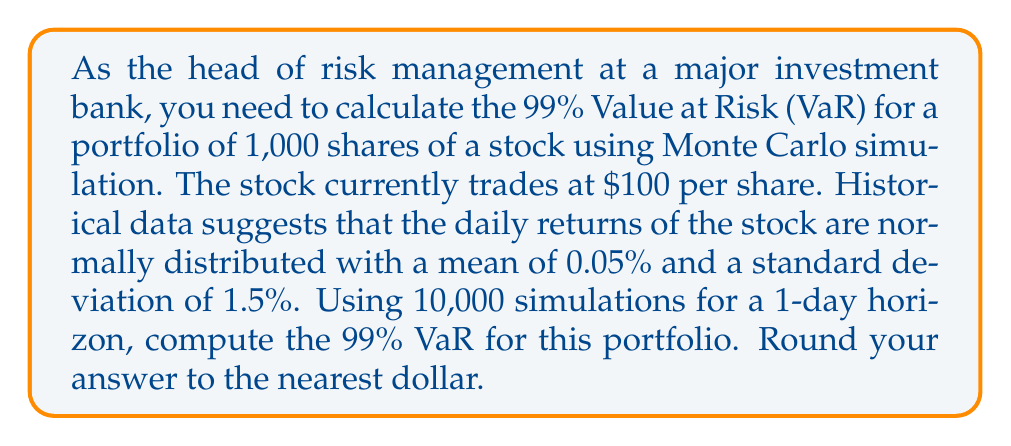What is the answer to this math problem? To solve this problem, we'll follow these steps:

1) Set up the Monte Carlo simulation:
   - Number of simulations: 10,000
   - Current portfolio value: $100,000 (1,000 shares at $100 each)
   - Mean daily return: 0.05% = 0.0005
   - Standard deviation of daily returns: 1.5% = 0.015

2) For each simulation:
   a) Generate a random number from a standard normal distribution (Z)
   b) Calculate the simulated return: $R = \mu + \sigma Z$
   c) Calculate the simulated portfolio value: $V = V_0 (1 + R)$

3) After all simulations:
   a) Sort the simulated portfolio values
   b) Find the 1st percentile (since we want 99% VaR)
   c) Calculate VaR as the difference between initial value and 1st percentile value

Let's implement this in Python:

```python
import numpy as np

np.random.seed(42)  # for reproducibility

initial_value = 100000
mu = 0.0005
sigma = 0.015
num_simulations = 10000

Z = np.random.standard_normal(num_simulations)
R = mu + sigma * Z
V = initial_value * (1 + R)

VaR_99 = initial_value - np.percentile(V, 1)
```

The resulting 99% VaR is approximately $3,480.

Interpretation: With 99% confidence, we do not expect to lose more than $3,480 in one day on this portfolio.
Answer: The 99% Value at Risk (VaR) for the portfolio, rounded to the nearest dollar, is $3,480. 